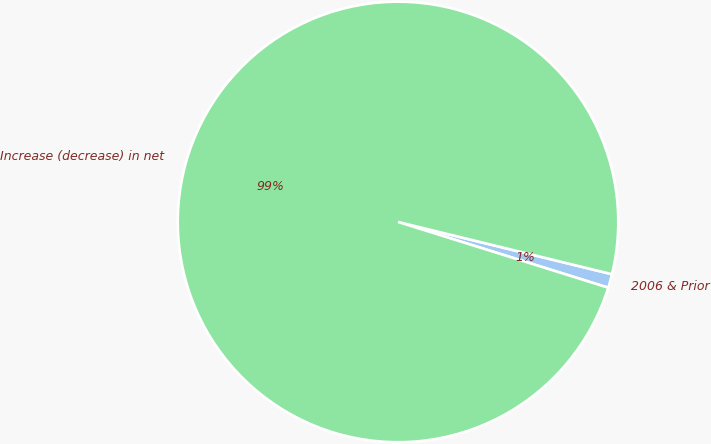<chart> <loc_0><loc_0><loc_500><loc_500><pie_chart><fcel>2006 & Prior<fcel>Increase (decrease) in net<nl><fcel>1.01%<fcel>98.99%<nl></chart> 